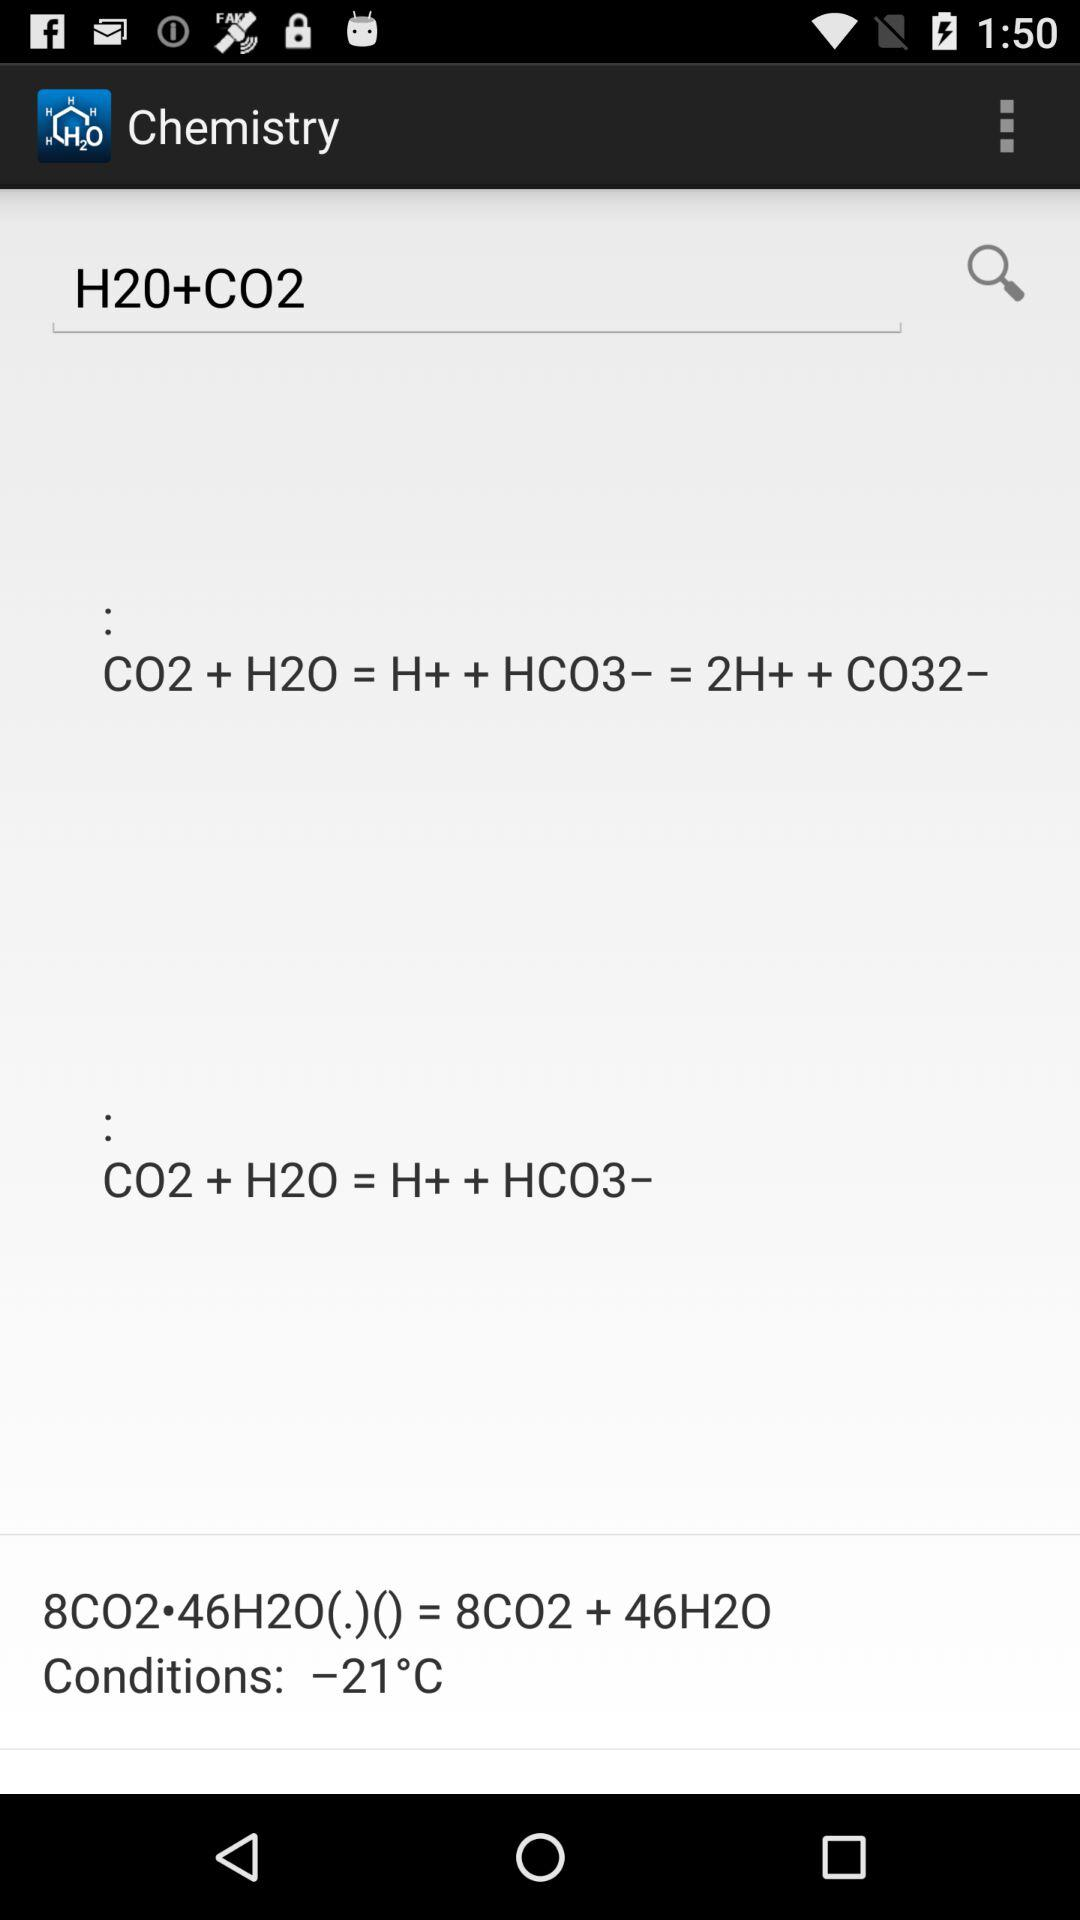How many H2O molecules are in the reaction?
Answer the question using a single word or phrase. 46 